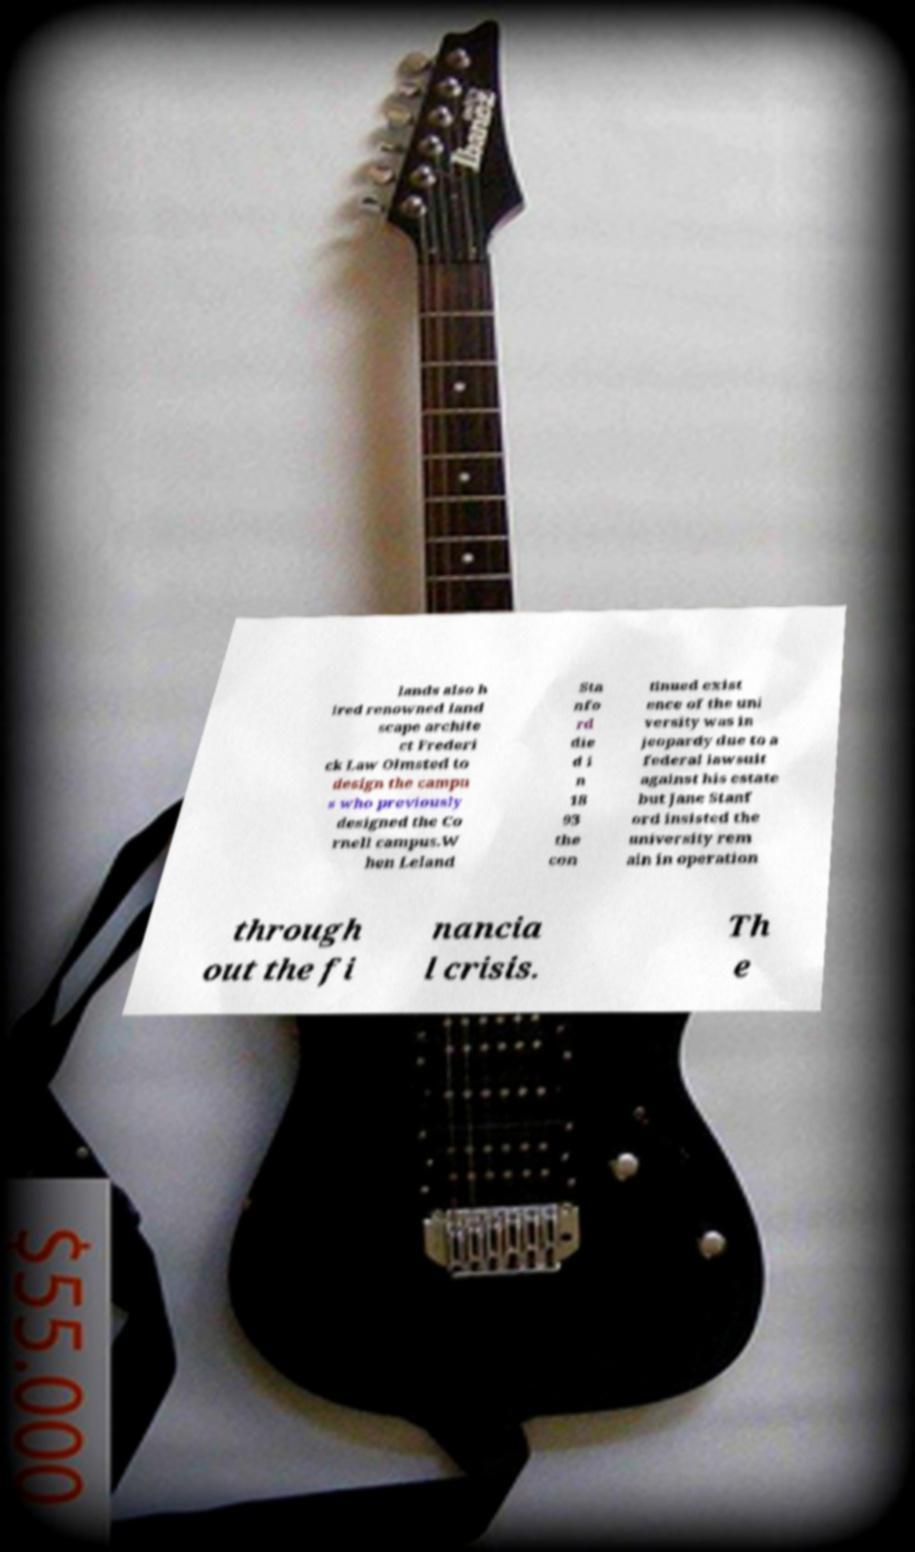Can you read and provide the text displayed in the image?This photo seems to have some interesting text. Can you extract and type it out for me? lands also h ired renowned land scape archite ct Frederi ck Law Olmsted to design the campu s who previously designed the Co rnell campus.W hen Leland Sta nfo rd die d i n 18 93 the con tinued exist ence of the uni versity was in jeopardy due to a federal lawsuit against his estate but Jane Stanf ord insisted the university rem ain in operation through out the fi nancia l crisis. Th e 